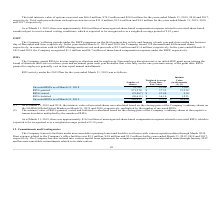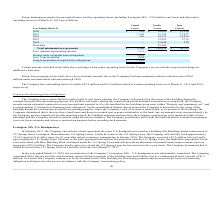According to Mimecast Limited's financial document, How much was the outstanding letters of credit related to certain operating leases as of March 31, 2019? According to the financial document, $3.9 million. The relevant text states: "The Company has outstanding letters of credit of $3.9 million and $3.8 million related to certain operating leases as of March 31, 2019 and 2018,..." Also, How much was the outstanding letters of credit related to certain operating leases as of March 31, 2018? According to the financial document, $3.8 million. The relevant text states: "outstanding letters of credit of $3.9 million and $3.8 million related to certain operating leases as of March 31, 2019 and 2018,..." Also, How much was the Rent expense related to the Company’s office facilities for the years ended March 31, 2019, 2018 and 2017 respectively? The document contains multiple relevant values: $5.3 million, $4.8 million, $3.2 million. From the document: "fice facilities was $5.3 million, $4.8 million and $3.2 million for the years ended March 31, 2019, 2018 and 2017, respectively. The Company has also ..." Also, can you calculate: What is the change in Facility Leases from Year Ending March 31, 2021 to 2022? Based on the calculation: 14,111-15,186, the result is -1075. This is based on the information: "2022 326 14,111 13,010 2021 1,102 15,186 17,427..." The key data points involved are: 14,111, 15,186. Also, can you calculate: What is the change in Facility Leases from Year Ending March 31, 2022 to 2023? Based on the calculation: 13,825-14,111, the result is -286. This is based on the information: "2022 326 14,111 13,010 2023 — 13,825 2,774..." The key data points involved are: 13,825, 14,111. Also, can you calculate: What is the change in Facility Leases from Year Ending March 31, 2023 to 2024? Based on the calculation: 13,686-13,825, the result is -139. This is based on the information: "2023 — 13,825 2,774 2024 — 13,686 356..." The key data points involved are: 13,686, 13,825. 